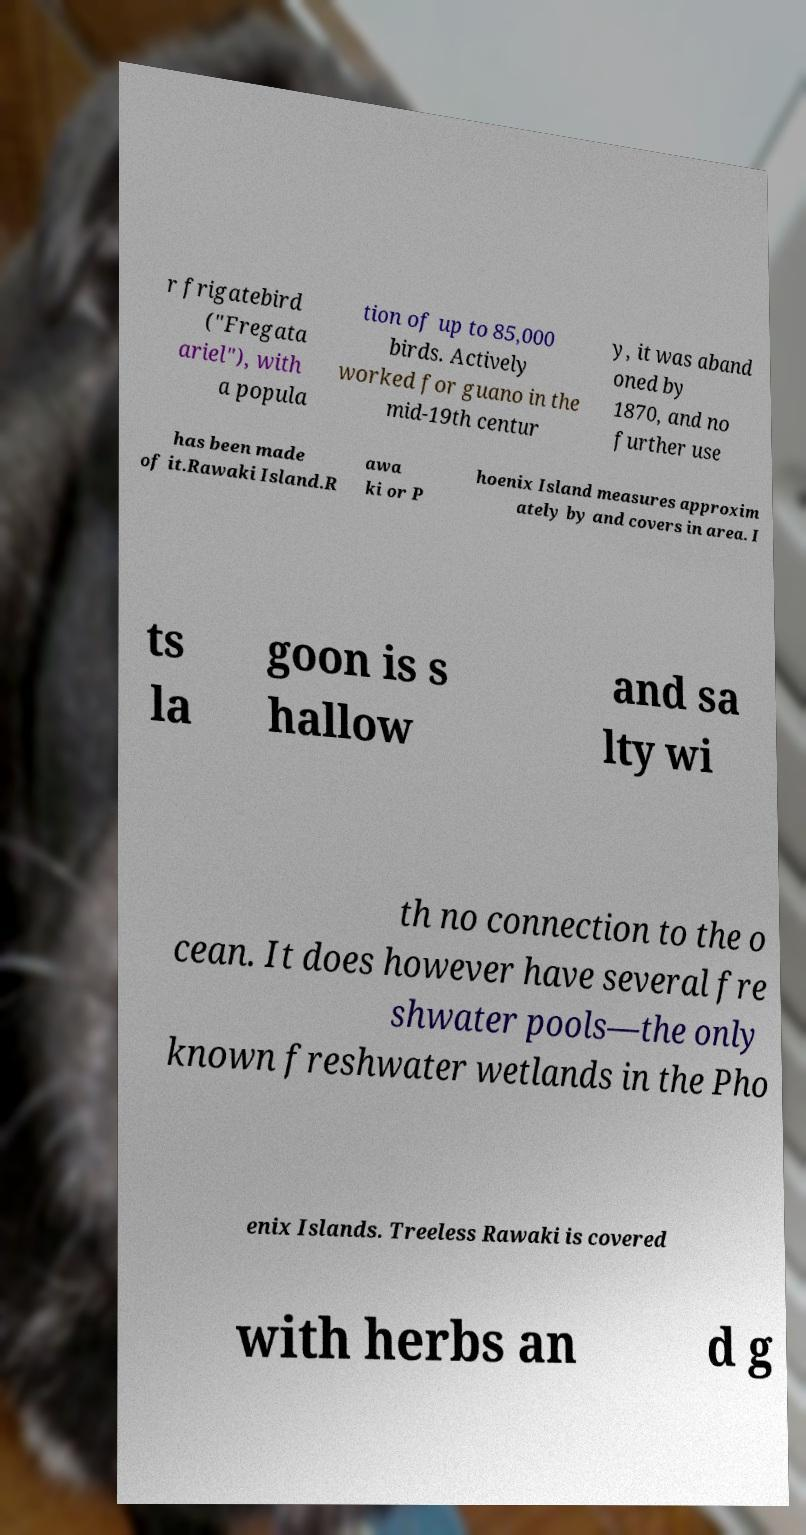What messages or text are displayed in this image? I need them in a readable, typed format. r frigatebird ("Fregata ariel"), with a popula tion of up to 85,000 birds. Actively worked for guano in the mid-19th centur y, it was aband oned by 1870, and no further use has been made of it.Rawaki Island.R awa ki or P hoenix Island measures approxim ately by and covers in area. I ts la goon is s hallow and sa lty wi th no connection to the o cean. It does however have several fre shwater pools—the only known freshwater wetlands in the Pho enix Islands. Treeless Rawaki is covered with herbs an d g 